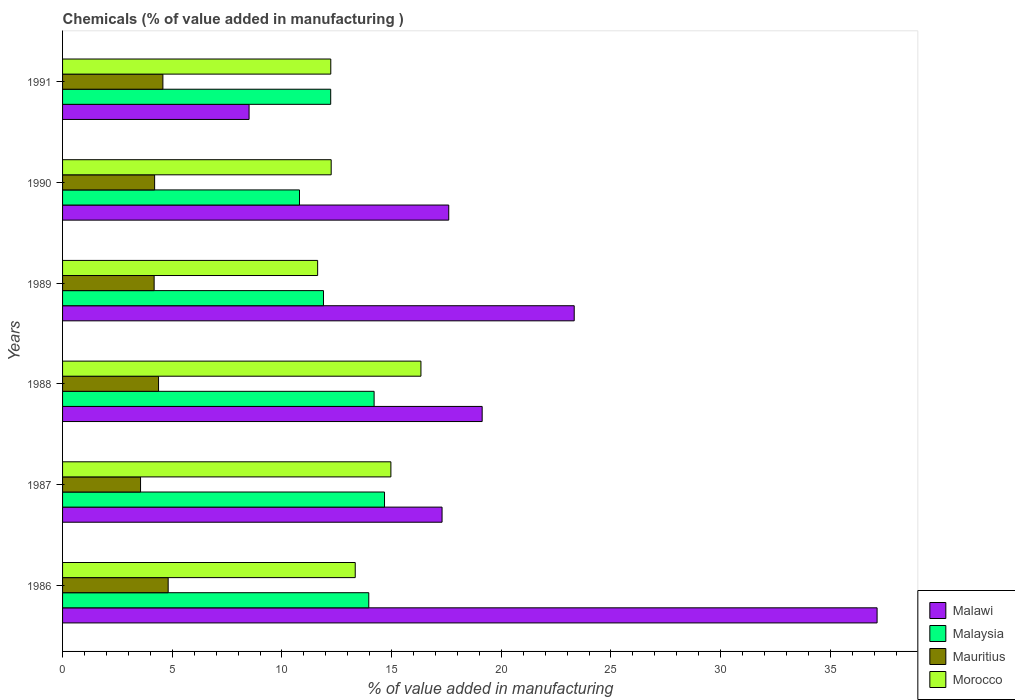How many different coloured bars are there?
Give a very brief answer. 4. How many groups of bars are there?
Make the answer very short. 6. Are the number of bars on each tick of the Y-axis equal?
Give a very brief answer. Yes. How many bars are there on the 5th tick from the top?
Offer a very short reply. 4. What is the value added in manufacturing chemicals in Malaysia in 1991?
Offer a terse response. 12.22. Across all years, what is the maximum value added in manufacturing chemicals in Mauritius?
Make the answer very short. 4.81. Across all years, what is the minimum value added in manufacturing chemicals in Malawi?
Make the answer very short. 8.5. What is the total value added in manufacturing chemicals in Malawi in the graph?
Your answer should be compact. 122.99. What is the difference between the value added in manufacturing chemicals in Mauritius in 1990 and that in 1991?
Keep it short and to the point. -0.38. What is the difference between the value added in manufacturing chemicals in Malawi in 1990 and the value added in manufacturing chemicals in Mauritius in 1987?
Make the answer very short. 14.05. What is the average value added in manufacturing chemicals in Morocco per year?
Your answer should be compact. 13.46. In the year 1991, what is the difference between the value added in manufacturing chemicals in Malawi and value added in manufacturing chemicals in Mauritius?
Offer a terse response. 3.93. What is the ratio of the value added in manufacturing chemicals in Malaysia in 1986 to that in 1988?
Give a very brief answer. 0.98. Is the value added in manufacturing chemicals in Mauritius in 1987 less than that in 1988?
Your answer should be compact. Yes. Is the difference between the value added in manufacturing chemicals in Malawi in 1986 and 1990 greater than the difference between the value added in manufacturing chemicals in Mauritius in 1986 and 1990?
Keep it short and to the point. Yes. What is the difference between the highest and the second highest value added in manufacturing chemicals in Malawi?
Provide a short and direct response. 13.81. What is the difference between the highest and the lowest value added in manufacturing chemicals in Malaysia?
Provide a short and direct response. 3.88. Is the sum of the value added in manufacturing chemicals in Mauritius in 1986 and 1989 greater than the maximum value added in manufacturing chemicals in Morocco across all years?
Ensure brevity in your answer.  No. Is it the case that in every year, the sum of the value added in manufacturing chemicals in Mauritius and value added in manufacturing chemicals in Malaysia is greater than the sum of value added in manufacturing chemicals in Malawi and value added in manufacturing chemicals in Morocco?
Your answer should be very brief. Yes. What does the 4th bar from the top in 1987 represents?
Offer a very short reply. Malawi. What does the 2nd bar from the bottom in 1990 represents?
Your response must be concise. Malaysia. How many bars are there?
Your answer should be compact. 24. How are the legend labels stacked?
Ensure brevity in your answer.  Vertical. What is the title of the graph?
Make the answer very short. Chemicals (% of value added in manufacturing ). What is the label or title of the X-axis?
Give a very brief answer. % of value added in manufacturing. What is the % of value added in manufacturing of Malawi in 1986?
Provide a short and direct response. 37.13. What is the % of value added in manufacturing in Malaysia in 1986?
Keep it short and to the point. 13.96. What is the % of value added in manufacturing of Mauritius in 1986?
Give a very brief answer. 4.81. What is the % of value added in manufacturing of Morocco in 1986?
Make the answer very short. 13.34. What is the % of value added in manufacturing of Malawi in 1987?
Provide a short and direct response. 17.3. What is the % of value added in manufacturing of Malaysia in 1987?
Offer a terse response. 14.68. What is the % of value added in manufacturing in Mauritius in 1987?
Give a very brief answer. 3.55. What is the % of value added in manufacturing of Morocco in 1987?
Your response must be concise. 14.97. What is the % of value added in manufacturing in Malawi in 1988?
Your answer should be very brief. 19.13. What is the % of value added in manufacturing of Malaysia in 1988?
Give a very brief answer. 14.2. What is the % of value added in manufacturing in Mauritius in 1988?
Offer a very short reply. 4.38. What is the % of value added in manufacturing in Morocco in 1988?
Provide a short and direct response. 16.34. What is the % of value added in manufacturing in Malawi in 1989?
Offer a very short reply. 23.32. What is the % of value added in manufacturing of Malaysia in 1989?
Provide a succinct answer. 11.89. What is the % of value added in manufacturing of Mauritius in 1989?
Your answer should be compact. 4.17. What is the % of value added in manufacturing in Morocco in 1989?
Make the answer very short. 11.63. What is the % of value added in manufacturing in Malawi in 1990?
Your response must be concise. 17.6. What is the % of value added in manufacturing of Malaysia in 1990?
Ensure brevity in your answer.  10.8. What is the % of value added in manufacturing of Mauritius in 1990?
Ensure brevity in your answer.  4.2. What is the % of value added in manufacturing in Morocco in 1990?
Provide a short and direct response. 12.25. What is the % of value added in manufacturing of Malawi in 1991?
Provide a succinct answer. 8.5. What is the % of value added in manufacturing in Malaysia in 1991?
Ensure brevity in your answer.  12.22. What is the % of value added in manufacturing in Mauritius in 1991?
Your answer should be compact. 4.57. What is the % of value added in manufacturing of Morocco in 1991?
Make the answer very short. 12.23. Across all years, what is the maximum % of value added in manufacturing of Malawi?
Your answer should be compact. 37.13. Across all years, what is the maximum % of value added in manufacturing of Malaysia?
Offer a terse response. 14.68. Across all years, what is the maximum % of value added in manufacturing of Mauritius?
Ensure brevity in your answer.  4.81. Across all years, what is the maximum % of value added in manufacturing in Morocco?
Make the answer very short. 16.34. Across all years, what is the minimum % of value added in manufacturing in Malawi?
Your answer should be very brief. 8.5. Across all years, what is the minimum % of value added in manufacturing in Malaysia?
Your answer should be very brief. 10.8. Across all years, what is the minimum % of value added in manufacturing of Mauritius?
Provide a succinct answer. 3.55. Across all years, what is the minimum % of value added in manufacturing in Morocco?
Offer a very short reply. 11.63. What is the total % of value added in manufacturing in Malawi in the graph?
Your response must be concise. 122.99. What is the total % of value added in manufacturing in Malaysia in the graph?
Give a very brief answer. 77.76. What is the total % of value added in manufacturing of Mauritius in the graph?
Give a very brief answer. 25.69. What is the total % of value added in manufacturing in Morocco in the graph?
Provide a short and direct response. 80.75. What is the difference between the % of value added in manufacturing in Malawi in 1986 and that in 1987?
Keep it short and to the point. 19.83. What is the difference between the % of value added in manufacturing of Malaysia in 1986 and that in 1987?
Provide a short and direct response. -0.72. What is the difference between the % of value added in manufacturing of Mauritius in 1986 and that in 1987?
Give a very brief answer. 1.26. What is the difference between the % of value added in manufacturing in Morocco in 1986 and that in 1987?
Make the answer very short. -1.63. What is the difference between the % of value added in manufacturing in Malawi in 1986 and that in 1988?
Your answer should be very brief. 18. What is the difference between the % of value added in manufacturing of Malaysia in 1986 and that in 1988?
Give a very brief answer. -0.24. What is the difference between the % of value added in manufacturing in Mauritius in 1986 and that in 1988?
Ensure brevity in your answer.  0.44. What is the difference between the % of value added in manufacturing of Morocco in 1986 and that in 1988?
Provide a short and direct response. -3. What is the difference between the % of value added in manufacturing in Malawi in 1986 and that in 1989?
Your response must be concise. 13.81. What is the difference between the % of value added in manufacturing of Malaysia in 1986 and that in 1989?
Your response must be concise. 2.06. What is the difference between the % of value added in manufacturing in Mauritius in 1986 and that in 1989?
Give a very brief answer. 0.64. What is the difference between the % of value added in manufacturing in Morocco in 1986 and that in 1989?
Offer a terse response. 1.71. What is the difference between the % of value added in manufacturing of Malawi in 1986 and that in 1990?
Ensure brevity in your answer.  19.53. What is the difference between the % of value added in manufacturing in Malaysia in 1986 and that in 1990?
Keep it short and to the point. 3.16. What is the difference between the % of value added in manufacturing in Mauritius in 1986 and that in 1990?
Your response must be concise. 0.62. What is the difference between the % of value added in manufacturing in Morocco in 1986 and that in 1990?
Your answer should be compact. 1.1. What is the difference between the % of value added in manufacturing in Malawi in 1986 and that in 1991?
Offer a very short reply. 28.63. What is the difference between the % of value added in manufacturing in Malaysia in 1986 and that in 1991?
Your response must be concise. 1.74. What is the difference between the % of value added in manufacturing of Mauritius in 1986 and that in 1991?
Make the answer very short. 0.24. What is the difference between the % of value added in manufacturing in Morocco in 1986 and that in 1991?
Your answer should be very brief. 1.11. What is the difference between the % of value added in manufacturing in Malawi in 1987 and that in 1988?
Provide a short and direct response. -1.83. What is the difference between the % of value added in manufacturing in Malaysia in 1987 and that in 1988?
Ensure brevity in your answer.  0.47. What is the difference between the % of value added in manufacturing of Mauritius in 1987 and that in 1988?
Provide a short and direct response. -0.82. What is the difference between the % of value added in manufacturing in Morocco in 1987 and that in 1988?
Make the answer very short. -1.37. What is the difference between the % of value added in manufacturing in Malawi in 1987 and that in 1989?
Make the answer very short. -6.02. What is the difference between the % of value added in manufacturing of Malaysia in 1987 and that in 1989?
Make the answer very short. 2.78. What is the difference between the % of value added in manufacturing of Mauritius in 1987 and that in 1989?
Provide a succinct answer. -0.62. What is the difference between the % of value added in manufacturing in Morocco in 1987 and that in 1989?
Your response must be concise. 3.34. What is the difference between the % of value added in manufacturing of Malawi in 1987 and that in 1990?
Ensure brevity in your answer.  -0.31. What is the difference between the % of value added in manufacturing of Malaysia in 1987 and that in 1990?
Offer a very short reply. 3.88. What is the difference between the % of value added in manufacturing in Mauritius in 1987 and that in 1990?
Make the answer very short. -0.64. What is the difference between the % of value added in manufacturing of Morocco in 1987 and that in 1990?
Make the answer very short. 2.72. What is the difference between the % of value added in manufacturing of Malawi in 1987 and that in 1991?
Provide a succinct answer. 8.8. What is the difference between the % of value added in manufacturing in Malaysia in 1987 and that in 1991?
Your response must be concise. 2.45. What is the difference between the % of value added in manufacturing of Mauritius in 1987 and that in 1991?
Offer a very short reply. -1.02. What is the difference between the % of value added in manufacturing in Morocco in 1987 and that in 1991?
Provide a short and direct response. 2.74. What is the difference between the % of value added in manufacturing in Malawi in 1988 and that in 1989?
Ensure brevity in your answer.  -4.2. What is the difference between the % of value added in manufacturing in Malaysia in 1988 and that in 1989?
Your response must be concise. 2.31. What is the difference between the % of value added in manufacturing of Mauritius in 1988 and that in 1989?
Ensure brevity in your answer.  0.2. What is the difference between the % of value added in manufacturing of Morocco in 1988 and that in 1989?
Provide a succinct answer. 4.71. What is the difference between the % of value added in manufacturing in Malawi in 1988 and that in 1990?
Your answer should be compact. 1.52. What is the difference between the % of value added in manufacturing in Malaysia in 1988 and that in 1990?
Give a very brief answer. 3.4. What is the difference between the % of value added in manufacturing in Mauritius in 1988 and that in 1990?
Provide a succinct answer. 0.18. What is the difference between the % of value added in manufacturing in Morocco in 1988 and that in 1990?
Keep it short and to the point. 4.09. What is the difference between the % of value added in manufacturing in Malawi in 1988 and that in 1991?
Give a very brief answer. 10.63. What is the difference between the % of value added in manufacturing in Malaysia in 1988 and that in 1991?
Your answer should be very brief. 1.98. What is the difference between the % of value added in manufacturing in Mauritius in 1988 and that in 1991?
Provide a short and direct response. -0.2. What is the difference between the % of value added in manufacturing of Morocco in 1988 and that in 1991?
Keep it short and to the point. 4.11. What is the difference between the % of value added in manufacturing of Malawi in 1989 and that in 1990?
Provide a succinct answer. 5.72. What is the difference between the % of value added in manufacturing in Malaysia in 1989 and that in 1990?
Provide a succinct answer. 1.09. What is the difference between the % of value added in manufacturing in Mauritius in 1989 and that in 1990?
Ensure brevity in your answer.  -0.02. What is the difference between the % of value added in manufacturing of Morocco in 1989 and that in 1990?
Your answer should be very brief. -0.62. What is the difference between the % of value added in manufacturing in Malawi in 1989 and that in 1991?
Keep it short and to the point. 14.82. What is the difference between the % of value added in manufacturing in Malaysia in 1989 and that in 1991?
Offer a terse response. -0.33. What is the difference between the % of value added in manufacturing in Mauritius in 1989 and that in 1991?
Your response must be concise. -0.4. What is the difference between the % of value added in manufacturing in Morocco in 1989 and that in 1991?
Offer a very short reply. -0.6. What is the difference between the % of value added in manufacturing in Malawi in 1990 and that in 1991?
Your answer should be compact. 9.1. What is the difference between the % of value added in manufacturing of Malaysia in 1990 and that in 1991?
Offer a very short reply. -1.42. What is the difference between the % of value added in manufacturing of Mauritius in 1990 and that in 1991?
Make the answer very short. -0.38. What is the difference between the % of value added in manufacturing in Morocco in 1990 and that in 1991?
Give a very brief answer. 0.02. What is the difference between the % of value added in manufacturing of Malawi in 1986 and the % of value added in manufacturing of Malaysia in 1987?
Your answer should be compact. 22.45. What is the difference between the % of value added in manufacturing of Malawi in 1986 and the % of value added in manufacturing of Mauritius in 1987?
Offer a very short reply. 33.58. What is the difference between the % of value added in manufacturing of Malawi in 1986 and the % of value added in manufacturing of Morocco in 1987?
Make the answer very short. 22.16. What is the difference between the % of value added in manufacturing in Malaysia in 1986 and the % of value added in manufacturing in Mauritius in 1987?
Your response must be concise. 10.4. What is the difference between the % of value added in manufacturing in Malaysia in 1986 and the % of value added in manufacturing in Morocco in 1987?
Make the answer very short. -1.01. What is the difference between the % of value added in manufacturing in Mauritius in 1986 and the % of value added in manufacturing in Morocco in 1987?
Your answer should be compact. -10.15. What is the difference between the % of value added in manufacturing of Malawi in 1986 and the % of value added in manufacturing of Malaysia in 1988?
Ensure brevity in your answer.  22.93. What is the difference between the % of value added in manufacturing in Malawi in 1986 and the % of value added in manufacturing in Mauritius in 1988?
Offer a terse response. 32.76. What is the difference between the % of value added in manufacturing of Malawi in 1986 and the % of value added in manufacturing of Morocco in 1988?
Offer a very short reply. 20.79. What is the difference between the % of value added in manufacturing of Malaysia in 1986 and the % of value added in manufacturing of Mauritius in 1988?
Your answer should be compact. 9.58. What is the difference between the % of value added in manufacturing of Malaysia in 1986 and the % of value added in manufacturing of Morocco in 1988?
Your answer should be very brief. -2.38. What is the difference between the % of value added in manufacturing of Mauritius in 1986 and the % of value added in manufacturing of Morocco in 1988?
Your response must be concise. -11.52. What is the difference between the % of value added in manufacturing in Malawi in 1986 and the % of value added in manufacturing in Malaysia in 1989?
Keep it short and to the point. 25.24. What is the difference between the % of value added in manufacturing in Malawi in 1986 and the % of value added in manufacturing in Mauritius in 1989?
Offer a very short reply. 32.96. What is the difference between the % of value added in manufacturing of Malawi in 1986 and the % of value added in manufacturing of Morocco in 1989?
Offer a very short reply. 25.5. What is the difference between the % of value added in manufacturing of Malaysia in 1986 and the % of value added in manufacturing of Mauritius in 1989?
Provide a short and direct response. 9.78. What is the difference between the % of value added in manufacturing in Malaysia in 1986 and the % of value added in manufacturing in Morocco in 1989?
Your answer should be compact. 2.33. What is the difference between the % of value added in manufacturing of Mauritius in 1986 and the % of value added in manufacturing of Morocco in 1989?
Provide a short and direct response. -6.81. What is the difference between the % of value added in manufacturing of Malawi in 1986 and the % of value added in manufacturing of Malaysia in 1990?
Keep it short and to the point. 26.33. What is the difference between the % of value added in manufacturing of Malawi in 1986 and the % of value added in manufacturing of Mauritius in 1990?
Provide a short and direct response. 32.94. What is the difference between the % of value added in manufacturing in Malawi in 1986 and the % of value added in manufacturing in Morocco in 1990?
Your answer should be compact. 24.89. What is the difference between the % of value added in manufacturing of Malaysia in 1986 and the % of value added in manufacturing of Mauritius in 1990?
Give a very brief answer. 9.76. What is the difference between the % of value added in manufacturing in Malaysia in 1986 and the % of value added in manufacturing in Morocco in 1990?
Provide a short and direct response. 1.71. What is the difference between the % of value added in manufacturing in Mauritius in 1986 and the % of value added in manufacturing in Morocco in 1990?
Make the answer very short. -7.43. What is the difference between the % of value added in manufacturing of Malawi in 1986 and the % of value added in manufacturing of Malaysia in 1991?
Offer a terse response. 24.91. What is the difference between the % of value added in manufacturing of Malawi in 1986 and the % of value added in manufacturing of Mauritius in 1991?
Ensure brevity in your answer.  32.56. What is the difference between the % of value added in manufacturing of Malawi in 1986 and the % of value added in manufacturing of Morocco in 1991?
Provide a short and direct response. 24.9. What is the difference between the % of value added in manufacturing in Malaysia in 1986 and the % of value added in manufacturing in Mauritius in 1991?
Offer a terse response. 9.39. What is the difference between the % of value added in manufacturing of Malaysia in 1986 and the % of value added in manufacturing of Morocco in 1991?
Provide a succinct answer. 1.73. What is the difference between the % of value added in manufacturing of Mauritius in 1986 and the % of value added in manufacturing of Morocco in 1991?
Your response must be concise. -7.41. What is the difference between the % of value added in manufacturing in Malawi in 1987 and the % of value added in manufacturing in Malaysia in 1988?
Provide a short and direct response. 3.1. What is the difference between the % of value added in manufacturing of Malawi in 1987 and the % of value added in manufacturing of Mauritius in 1988?
Your answer should be very brief. 12.92. What is the difference between the % of value added in manufacturing in Malawi in 1987 and the % of value added in manufacturing in Morocco in 1988?
Ensure brevity in your answer.  0.96. What is the difference between the % of value added in manufacturing in Malaysia in 1987 and the % of value added in manufacturing in Mauritius in 1988?
Provide a short and direct response. 10.3. What is the difference between the % of value added in manufacturing in Malaysia in 1987 and the % of value added in manufacturing in Morocco in 1988?
Make the answer very short. -1.66. What is the difference between the % of value added in manufacturing in Mauritius in 1987 and the % of value added in manufacturing in Morocco in 1988?
Provide a succinct answer. -12.78. What is the difference between the % of value added in manufacturing of Malawi in 1987 and the % of value added in manufacturing of Malaysia in 1989?
Ensure brevity in your answer.  5.41. What is the difference between the % of value added in manufacturing in Malawi in 1987 and the % of value added in manufacturing in Mauritius in 1989?
Provide a short and direct response. 13.12. What is the difference between the % of value added in manufacturing of Malawi in 1987 and the % of value added in manufacturing of Morocco in 1989?
Keep it short and to the point. 5.67. What is the difference between the % of value added in manufacturing in Malaysia in 1987 and the % of value added in manufacturing in Mauritius in 1989?
Provide a succinct answer. 10.5. What is the difference between the % of value added in manufacturing of Malaysia in 1987 and the % of value added in manufacturing of Morocco in 1989?
Offer a terse response. 3.05. What is the difference between the % of value added in manufacturing of Mauritius in 1987 and the % of value added in manufacturing of Morocco in 1989?
Give a very brief answer. -8.07. What is the difference between the % of value added in manufacturing in Malawi in 1987 and the % of value added in manufacturing in Malaysia in 1990?
Offer a terse response. 6.5. What is the difference between the % of value added in manufacturing in Malawi in 1987 and the % of value added in manufacturing in Mauritius in 1990?
Offer a very short reply. 13.1. What is the difference between the % of value added in manufacturing in Malawi in 1987 and the % of value added in manufacturing in Morocco in 1990?
Keep it short and to the point. 5.05. What is the difference between the % of value added in manufacturing in Malaysia in 1987 and the % of value added in manufacturing in Mauritius in 1990?
Ensure brevity in your answer.  10.48. What is the difference between the % of value added in manufacturing of Malaysia in 1987 and the % of value added in manufacturing of Morocco in 1990?
Your response must be concise. 2.43. What is the difference between the % of value added in manufacturing of Mauritius in 1987 and the % of value added in manufacturing of Morocco in 1990?
Your response must be concise. -8.69. What is the difference between the % of value added in manufacturing of Malawi in 1987 and the % of value added in manufacturing of Malaysia in 1991?
Your answer should be compact. 5.08. What is the difference between the % of value added in manufacturing in Malawi in 1987 and the % of value added in manufacturing in Mauritius in 1991?
Offer a terse response. 12.73. What is the difference between the % of value added in manufacturing of Malawi in 1987 and the % of value added in manufacturing of Morocco in 1991?
Give a very brief answer. 5.07. What is the difference between the % of value added in manufacturing of Malaysia in 1987 and the % of value added in manufacturing of Mauritius in 1991?
Your answer should be very brief. 10.1. What is the difference between the % of value added in manufacturing of Malaysia in 1987 and the % of value added in manufacturing of Morocco in 1991?
Offer a very short reply. 2.45. What is the difference between the % of value added in manufacturing in Mauritius in 1987 and the % of value added in manufacturing in Morocco in 1991?
Your answer should be compact. -8.67. What is the difference between the % of value added in manufacturing of Malawi in 1988 and the % of value added in manufacturing of Malaysia in 1989?
Ensure brevity in your answer.  7.23. What is the difference between the % of value added in manufacturing of Malawi in 1988 and the % of value added in manufacturing of Mauritius in 1989?
Your response must be concise. 14.95. What is the difference between the % of value added in manufacturing of Malaysia in 1988 and the % of value added in manufacturing of Mauritius in 1989?
Provide a succinct answer. 10.03. What is the difference between the % of value added in manufacturing of Malaysia in 1988 and the % of value added in manufacturing of Morocco in 1989?
Your answer should be compact. 2.57. What is the difference between the % of value added in manufacturing in Mauritius in 1988 and the % of value added in manufacturing in Morocco in 1989?
Provide a short and direct response. -7.25. What is the difference between the % of value added in manufacturing in Malawi in 1988 and the % of value added in manufacturing in Malaysia in 1990?
Keep it short and to the point. 8.33. What is the difference between the % of value added in manufacturing in Malawi in 1988 and the % of value added in manufacturing in Mauritius in 1990?
Keep it short and to the point. 14.93. What is the difference between the % of value added in manufacturing of Malawi in 1988 and the % of value added in manufacturing of Morocco in 1990?
Your answer should be compact. 6.88. What is the difference between the % of value added in manufacturing of Malaysia in 1988 and the % of value added in manufacturing of Mauritius in 1990?
Provide a short and direct response. 10.01. What is the difference between the % of value added in manufacturing of Malaysia in 1988 and the % of value added in manufacturing of Morocco in 1990?
Your response must be concise. 1.96. What is the difference between the % of value added in manufacturing of Mauritius in 1988 and the % of value added in manufacturing of Morocco in 1990?
Your answer should be compact. -7.87. What is the difference between the % of value added in manufacturing of Malawi in 1988 and the % of value added in manufacturing of Malaysia in 1991?
Make the answer very short. 6.9. What is the difference between the % of value added in manufacturing of Malawi in 1988 and the % of value added in manufacturing of Mauritius in 1991?
Your answer should be compact. 14.55. What is the difference between the % of value added in manufacturing of Malawi in 1988 and the % of value added in manufacturing of Morocco in 1991?
Give a very brief answer. 6.9. What is the difference between the % of value added in manufacturing in Malaysia in 1988 and the % of value added in manufacturing in Mauritius in 1991?
Provide a succinct answer. 9.63. What is the difference between the % of value added in manufacturing in Malaysia in 1988 and the % of value added in manufacturing in Morocco in 1991?
Provide a succinct answer. 1.98. What is the difference between the % of value added in manufacturing in Mauritius in 1988 and the % of value added in manufacturing in Morocco in 1991?
Provide a short and direct response. -7.85. What is the difference between the % of value added in manufacturing in Malawi in 1989 and the % of value added in manufacturing in Malaysia in 1990?
Ensure brevity in your answer.  12.52. What is the difference between the % of value added in manufacturing in Malawi in 1989 and the % of value added in manufacturing in Mauritius in 1990?
Keep it short and to the point. 19.13. What is the difference between the % of value added in manufacturing of Malawi in 1989 and the % of value added in manufacturing of Morocco in 1990?
Make the answer very short. 11.08. What is the difference between the % of value added in manufacturing of Malaysia in 1989 and the % of value added in manufacturing of Mauritius in 1990?
Provide a short and direct response. 7.7. What is the difference between the % of value added in manufacturing in Malaysia in 1989 and the % of value added in manufacturing in Morocco in 1990?
Provide a succinct answer. -0.35. What is the difference between the % of value added in manufacturing in Mauritius in 1989 and the % of value added in manufacturing in Morocco in 1990?
Your response must be concise. -8.07. What is the difference between the % of value added in manufacturing of Malawi in 1989 and the % of value added in manufacturing of Malaysia in 1991?
Offer a very short reply. 11.1. What is the difference between the % of value added in manufacturing in Malawi in 1989 and the % of value added in manufacturing in Mauritius in 1991?
Provide a short and direct response. 18.75. What is the difference between the % of value added in manufacturing of Malawi in 1989 and the % of value added in manufacturing of Morocco in 1991?
Give a very brief answer. 11.1. What is the difference between the % of value added in manufacturing of Malaysia in 1989 and the % of value added in manufacturing of Mauritius in 1991?
Provide a succinct answer. 7.32. What is the difference between the % of value added in manufacturing of Malaysia in 1989 and the % of value added in manufacturing of Morocco in 1991?
Provide a short and direct response. -0.33. What is the difference between the % of value added in manufacturing in Mauritius in 1989 and the % of value added in manufacturing in Morocco in 1991?
Your answer should be compact. -8.05. What is the difference between the % of value added in manufacturing in Malawi in 1990 and the % of value added in manufacturing in Malaysia in 1991?
Your answer should be very brief. 5.38. What is the difference between the % of value added in manufacturing in Malawi in 1990 and the % of value added in manufacturing in Mauritius in 1991?
Offer a very short reply. 13.03. What is the difference between the % of value added in manufacturing in Malawi in 1990 and the % of value added in manufacturing in Morocco in 1991?
Provide a short and direct response. 5.38. What is the difference between the % of value added in manufacturing in Malaysia in 1990 and the % of value added in manufacturing in Mauritius in 1991?
Keep it short and to the point. 6.23. What is the difference between the % of value added in manufacturing in Malaysia in 1990 and the % of value added in manufacturing in Morocco in 1991?
Provide a short and direct response. -1.43. What is the difference between the % of value added in manufacturing in Mauritius in 1990 and the % of value added in manufacturing in Morocco in 1991?
Offer a terse response. -8.03. What is the average % of value added in manufacturing in Malawi per year?
Provide a short and direct response. 20.5. What is the average % of value added in manufacturing of Malaysia per year?
Your response must be concise. 12.96. What is the average % of value added in manufacturing in Mauritius per year?
Your answer should be very brief. 4.28. What is the average % of value added in manufacturing in Morocco per year?
Your answer should be compact. 13.46. In the year 1986, what is the difference between the % of value added in manufacturing in Malawi and % of value added in manufacturing in Malaysia?
Your response must be concise. 23.17. In the year 1986, what is the difference between the % of value added in manufacturing in Malawi and % of value added in manufacturing in Mauritius?
Provide a short and direct response. 32.32. In the year 1986, what is the difference between the % of value added in manufacturing in Malawi and % of value added in manufacturing in Morocco?
Your answer should be very brief. 23.79. In the year 1986, what is the difference between the % of value added in manufacturing of Malaysia and % of value added in manufacturing of Mauritius?
Provide a succinct answer. 9.15. In the year 1986, what is the difference between the % of value added in manufacturing in Malaysia and % of value added in manufacturing in Morocco?
Your response must be concise. 0.62. In the year 1986, what is the difference between the % of value added in manufacturing in Mauritius and % of value added in manufacturing in Morocco?
Ensure brevity in your answer.  -8.53. In the year 1987, what is the difference between the % of value added in manufacturing of Malawi and % of value added in manufacturing of Malaysia?
Provide a succinct answer. 2.62. In the year 1987, what is the difference between the % of value added in manufacturing in Malawi and % of value added in manufacturing in Mauritius?
Provide a succinct answer. 13.74. In the year 1987, what is the difference between the % of value added in manufacturing in Malawi and % of value added in manufacturing in Morocco?
Make the answer very short. 2.33. In the year 1987, what is the difference between the % of value added in manufacturing in Malaysia and % of value added in manufacturing in Mauritius?
Offer a very short reply. 11.12. In the year 1987, what is the difference between the % of value added in manufacturing of Malaysia and % of value added in manufacturing of Morocco?
Offer a terse response. -0.29. In the year 1987, what is the difference between the % of value added in manufacturing in Mauritius and % of value added in manufacturing in Morocco?
Ensure brevity in your answer.  -11.41. In the year 1988, what is the difference between the % of value added in manufacturing of Malawi and % of value added in manufacturing of Malaysia?
Your response must be concise. 4.93. In the year 1988, what is the difference between the % of value added in manufacturing of Malawi and % of value added in manufacturing of Mauritius?
Provide a short and direct response. 14.75. In the year 1988, what is the difference between the % of value added in manufacturing of Malawi and % of value added in manufacturing of Morocco?
Your answer should be compact. 2.79. In the year 1988, what is the difference between the % of value added in manufacturing in Malaysia and % of value added in manufacturing in Mauritius?
Give a very brief answer. 9.83. In the year 1988, what is the difference between the % of value added in manufacturing in Malaysia and % of value added in manufacturing in Morocco?
Your answer should be very brief. -2.13. In the year 1988, what is the difference between the % of value added in manufacturing of Mauritius and % of value added in manufacturing of Morocco?
Your answer should be compact. -11.96. In the year 1989, what is the difference between the % of value added in manufacturing of Malawi and % of value added in manufacturing of Malaysia?
Make the answer very short. 11.43. In the year 1989, what is the difference between the % of value added in manufacturing of Malawi and % of value added in manufacturing of Mauritius?
Ensure brevity in your answer.  19.15. In the year 1989, what is the difference between the % of value added in manufacturing in Malawi and % of value added in manufacturing in Morocco?
Keep it short and to the point. 11.7. In the year 1989, what is the difference between the % of value added in manufacturing in Malaysia and % of value added in manufacturing in Mauritius?
Offer a terse response. 7.72. In the year 1989, what is the difference between the % of value added in manufacturing of Malaysia and % of value added in manufacturing of Morocco?
Keep it short and to the point. 0.27. In the year 1989, what is the difference between the % of value added in manufacturing of Mauritius and % of value added in manufacturing of Morocco?
Make the answer very short. -7.45. In the year 1990, what is the difference between the % of value added in manufacturing of Malawi and % of value added in manufacturing of Malaysia?
Provide a succinct answer. 6.8. In the year 1990, what is the difference between the % of value added in manufacturing in Malawi and % of value added in manufacturing in Mauritius?
Make the answer very short. 13.41. In the year 1990, what is the difference between the % of value added in manufacturing of Malawi and % of value added in manufacturing of Morocco?
Provide a succinct answer. 5.36. In the year 1990, what is the difference between the % of value added in manufacturing of Malaysia and % of value added in manufacturing of Mauritius?
Make the answer very short. 6.6. In the year 1990, what is the difference between the % of value added in manufacturing in Malaysia and % of value added in manufacturing in Morocco?
Provide a succinct answer. -1.44. In the year 1990, what is the difference between the % of value added in manufacturing of Mauritius and % of value added in manufacturing of Morocco?
Your answer should be compact. -8.05. In the year 1991, what is the difference between the % of value added in manufacturing in Malawi and % of value added in manufacturing in Malaysia?
Provide a succinct answer. -3.72. In the year 1991, what is the difference between the % of value added in manufacturing in Malawi and % of value added in manufacturing in Mauritius?
Your answer should be compact. 3.93. In the year 1991, what is the difference between the % of value added in manufacturing in Malawi and % of value added in manufacturing in Morocco?
Your answer should be very brief. -3.72. In the year 1991, what is the difference between the % of value added in manufacturing in Malaysia and % of value added in manufacturing in Mauritius?
Give a very brief answer. 7.65. In the year 1991, what is the difference between the % of value added in manufacturing of Malaysia and % of value added in manufacturing of Morocco?
Your answer should be compact. -0. In the year 1991, what is the difference between the % of value added in manufacturing of Mauritius and % of value added in manufacturing of Morocco?
Your response must be concise. -7.65. What is the ratio of the % of value added in manufacturing in Malawi in 1986 to that in 1987?
Your answer should be very brief. 2.15. What is the ratio of the % of value added in manufacturing of Malaysia in 1986 to that in 1987?
Ensure brevity in your answer.  0.95. What is the ratio of the % of value added in manufacturing of Mauritius in 1986 to that in 1987?
Provide a short and direct response. 1.35. What is the ratio of the % of value added in manufacturing in Morocco in 1986 to that in 1987?
Provide a succinct answer. 0.89. What is the ratio of the % of value added in manufacturing in Malawi in 1986 to that in 1988?
Your response must be concise. 1.94. What is the ratio of the % of value added in manufacturing of Malaysia in 1986 to that in 1988?
Give a very brief answer. 0.98. What is the ratio of the % of value added in manufacturing in Mauritius in 1986 to that in 1988?
Your answer should be compact. 1.1. What is the ratio of the % of value added in manufacturing of Morocco in 1986 to that in 1988?
Your answer should be compact. 0.82. What is the ratio of the % of value added in manufacturing of Malawi in 1986 to that in 1989?
Your response must be concise. 1.59. What is the ratio of the % of value added in manufacturing in Malaysia in 1986 to that in 1989?
Provide a short and direct response. 1.17. What is the ratio of the % of value added in manufacturing in Mauritius in 1986 to that in 1989?
Provide a succinct answer. 1.15. What is the ratio of the % of value added in manufacturing in Morocco in 1986 to that in 1989?
Your answer should be very brief. 1.15. What is the ratio of the % of value added in manufacturing in Malawi in 1986 to that in 1990?
Your answer should be very brief. 2.11. What is the ratio of the % of value added in manufacturing in Malaysia in 1986 to that in 1990?
Offer a very short reply. 1.29. What is the ratio of the % of value added in manufacturing of Mauritius in 1986 to that in 1990?
Keep it short and to the point. 1.15. What is the ratio of the % of value added in manufacturing in Morocco in 1986 to that in 1990?
Your answer should be very brief. 1.09. What is the ratio of the % of value added in manufacturing in Malawi in 1986 to that in 1991?
Your answer should be very brief. 4.37. What is the ratio of the % of value added in manufacturing of Malaysia in 1986 to that in 1991?
Keep it short and to the point. 1.14. What is the ratio of the % of value added in manufacturing in Mauritius in 1986 to that in 1991?
Provide a short and direct response. 1.05. What is the ratio of the % of value added in manufacturing in Morocco in 1986 to that in 1991?
Your response must be concise. 1.09. What is the ratio of the % of value added in manufacturing in Malawi in 1987 to that in 1988?
Provide a short and direct response. 0.9. What is the ratio of the % of value added in manufacturing of Malaysia in 1987 to that in 1988?
Provide a succinct answer. 1.03. What is the ratio of the % of value added in manufacturing of Mauritius in 1987 to that in 1988?
Keep it short and to the point. 0.81. What is the ratio of the % of value added in manufacturing of Morocco in 1987 to that in 1988?
Your response must be concise. 0.92. What is the ratio of the % of value added in manufacturing in Malawi in 1987 to that in 1989?
Offer a very short reply. 0.74. What is the ratio of the % of value added in manufacturing of Malaysia in 1987 to that in 1989?
Give a very brief answer. 1.23. What is the ratio of the % of value added in manufacturing in Mauritius in 1987 to that in 1989?
Give a very brief answer. 0.85. What is the ratio of the % of value added in manufacturing in Morocco in 1987 to that in 1989?
Give a very brief answer. 1.29. What is the ratio of the % of value added in manufacturing of Malawi in 1987 to that in 1990?
Offer a terse response. 0.98. What is the ratio of the % of value added in manufacturing of Malaysia in 1987 to that in 1990?
Offer a terse response. 1.36. What is the ratio of the % of value added in manufacturing in Mauritius in 1987 to that in 1990?
Your response must be concise. 0.85. What is the ratio of the % of value added in manufacturing of Morocco in 1987 to that in 1990?
Provide a short and direct response. 1.22. What is the ratio of the % of value added in manufacturing of Malawi in 1987 to that in 1991?
Your answer should be compact. 2.03. What is the ratio of the % of value added in manufacturing of Malaysia in 1987 to that in 1991?
Ensure brevity in your answer.  1.2. What is the ratio of the % of value added in manufacturing of Mauritius in 1987 to that in 1991?
Your answer should be compact. 0.78. What is the ratio of the % of value added in manufacturing in Morocco in 1987 to that in 1991?
Offer a very short reply. 1.22. What is the ratio of the % of value added in manufacturing of Malawi in 1988 to that in 1989?
Offer a terse response. 0.82. What is the ratio of the % of value added in manufacturing in Malaysia in 1988 to that in 1989?
Ensure brevity in your answer.  1.19. What is the ratio of the % of value added in manufacturing in Mauritius in 1988 to that in 1989?
Provide a succinct answer. 1.05. What is the ratio of the % of value added in manufacturing in Morocco in 1988 to that in 1989?
Give a very brief answer. 1.41. What is the ratio of the % of value added in manufacturing in Malawi in 1988 to that in 1990?
Offer a terse response. 1.09. What is the ratio of the % of value added in manufacturing in Malaysia in 1988 to that in 1990?
Your answer should be very brief. 1.31. What is the ratio of the % of value added in manufacturing in Mauritius in 1988 to that in 1990?
Provide a succinct answer. 1.04. What is the ratio of the % of value added in manufacturing of Morocco in 1988 to that in 1990?
Provide a short and direct response. 1.33. What is the ratio of the % of value added in manufacturing in Malawi in 1988 to that in 1991?
Your answer should be very brief. 2.25. What is the ratio of the % of value added in manufacturing in Malaysia in 1988 to that in 1991?
Offer a terse response. 1.16. What is the ratio of the % of value added in manufacturing in Mauritius in 1988 to that in 1991?
Provide a short and direct response. 0.96. What is the ratio of the % of value added in manufacturing in Morocco in 1988 to that in 1991?
Your answer should be compact. 1.34. What is the ratio of the % of value added in manufacturing of Malawi in 1989 to that in 1990?
Make the answer very short. 1.32. What is the ratio of the % of value added in manufacturing of Malaysia in 1989 to that in 1990?
Make the answer very short. 1.1. What is the ratio of the % of value added in manufacturing in Morocco in 1989 to that in 1990?
Provide a succinct answer. 0.95. What is the ratio of the % of value added in manufacturing in Malawi in 1989 to that in 1991?
Provide a succinct answer. 2.74. What is the ratio of the % of value added in manufacturing in Malaysia in 1989 to that in 1991?
Ensure brevity in your answer.  0.97. What is the ratio of the % of value added in manufacturing of Mauritius in 1989 to that in 1991?
Your response must be concise. 0.91. What is the ratio of the % of value added in manufacturing of Morocco in 1989 to that in 1991?
Your response must be concise. 0.95. What is the ratio of the % of value added in manufacturing in Malawi in 1990 to that in 1991?
Offer a terse response. 2.07. What is the ratio of the % of value added in manufacturing in Malaysia in 1990 to that in 1991?
Your answer should be compact. 0.88. What is the ratio of the % of value added in manufacturing of Mauritius in 1990 to that in 1991?
Offer a very short reply. 0.92. What is the difference between the highest and the second highest % of value added in manufacturing in Malawi?
Make the answer very short. 13.81. What is the difference between the highest and the second highest % of value added in manufacturing in Malaysia?
Give a very brief answer. 0.47. What is the difference between the highest and the second highest % of value added in manufacturing in Mauritius?
Your answer should be compact. 0.24. What is the difference between the highest and the second highest % of value added in manufacturing of Morocco?
Your answer should be very brief. 1.37. What is the difference between the highest and the lowest % of value added in manufacturing of Malawi?
Keep it short and to the point. 28.63. What is the difference between the highest and the lowest % of value added in manufacturing in Malaysia?
Your answer should be very brief. 3.88. What is the difference between the highest and the lowest % of value added in manufacturing of Mauritius?
Offer a very short reply. 1.26. What is the difference between the highest and the lowest % of value added in manufacturing of Morocco?
Your answer should be compact. 4.71. 